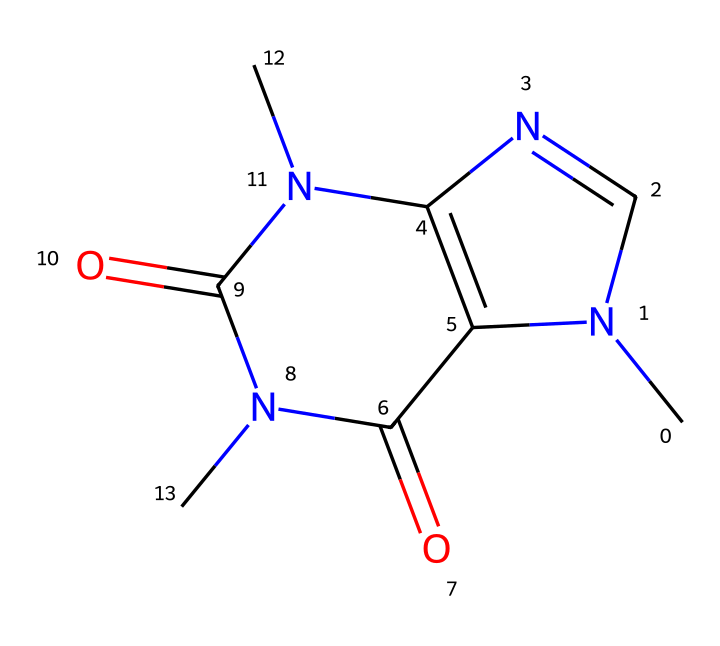What is the molecular formula of this structure? By analyzing the SMILES representation, we can deduce the molecular formula. Counting all the atoms indicated in the SMILES, we find there are 8 carbon (C) atoms, 10 hydrogen (H) atoms, 4 nitrogen (N) atoms, and 2 oxygen (O) atoms. Therefore, the molecular formula is C8H10N4O2.
Answer: C8H10N4O2 How many rings are present in this structure? In the SMILES representation, we identify two instances of "N1" and "N2", which signifies the formation of two interconnected rings. Upon visualizing, we confirm that there are two distinct ring structures present.
Answer: 2 What is the functional group present in this chemical? Observing the structure's components, particularly the multiple nitrogen atoms and carbonyl groups (C=O), we recognize that the chemical belongs to the class of nitrogenous bases, and typical functional groups include pyrimidines. In this case, it prominently features amide groups as well.
Answer: amide Which atoms in this compound can act as hydrogen bond donors? In this structure, the nitrogen and oxygen atoms are potential hydrogen bond donors. Nitrogen atoms (particularly in amide groups) have hydrogen atoms attached that can form hydrogen bonds. Therefore, the answer is nitrogen and oxygen.
Answer: nitrogen, oxygen What type of base is this compound? Given the structure and presence of nitrogen, particularly configured in a cyclic manner, this compound can be categorized as a purine derivative, indicating that it acts as a nitrogenous base in biological contexts.
Answer: purine Which part of this chemical contributes to its psychoactive properties? Analyzing the structure, the presence of nitrogen atoms in a cyclic structure is typical of many psychoactive compounds, as they can interact with neurotransmitters in the brain. Specifically, the configuration resembles that of caffeine.
Answer: nitrogen atoms 